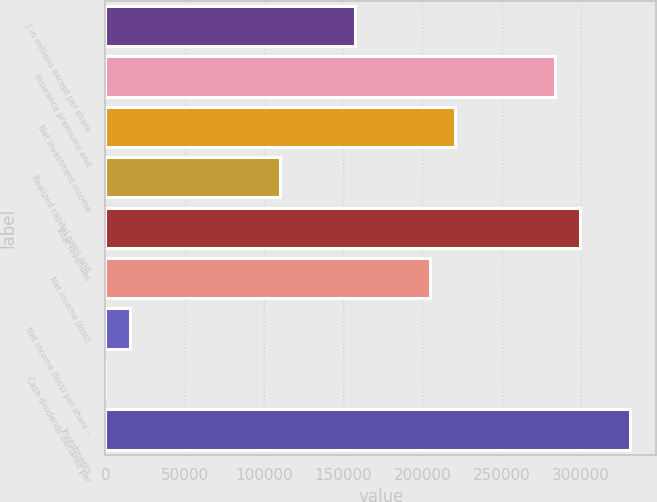<chart> <loc_0><loc_0><loc_500><loc_500><bar_chart><fcel>( in millions except per share<fcel>Insurance premiums and<fcel>Net investment income<fcel>Realized capital gains and<fcel>Total revenues<fcel>Net income (loss)<fcel>Net income (loss) per share -<fcel>Cash dividends declared per<fcel>Investments<nl><fcel>157554<fcel>283596<fcel>220575<fcel>110288<fcel>299351<fcel>204820<fcel>15756.7<fcel>1.4<fcel>330862<nl></chart> 